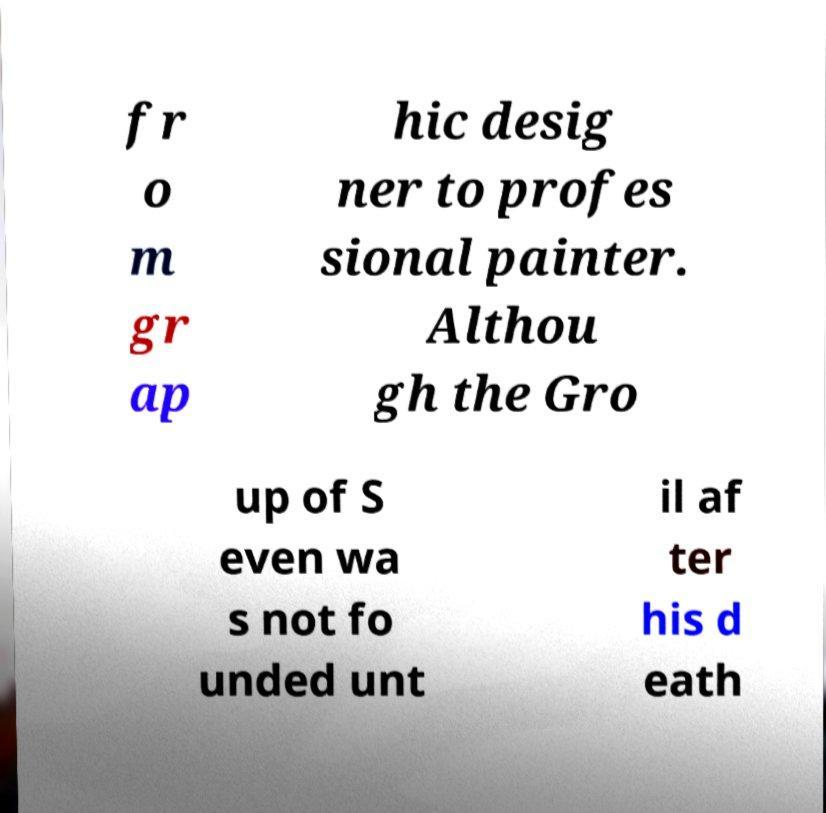Could you assist in decoding the text presented in this image and type it out clearly? fr o m gr ap hic desig ner to profes sional painter. Althou gh the Gro up of S even wa s not fo unded unt il af ter his d eath 